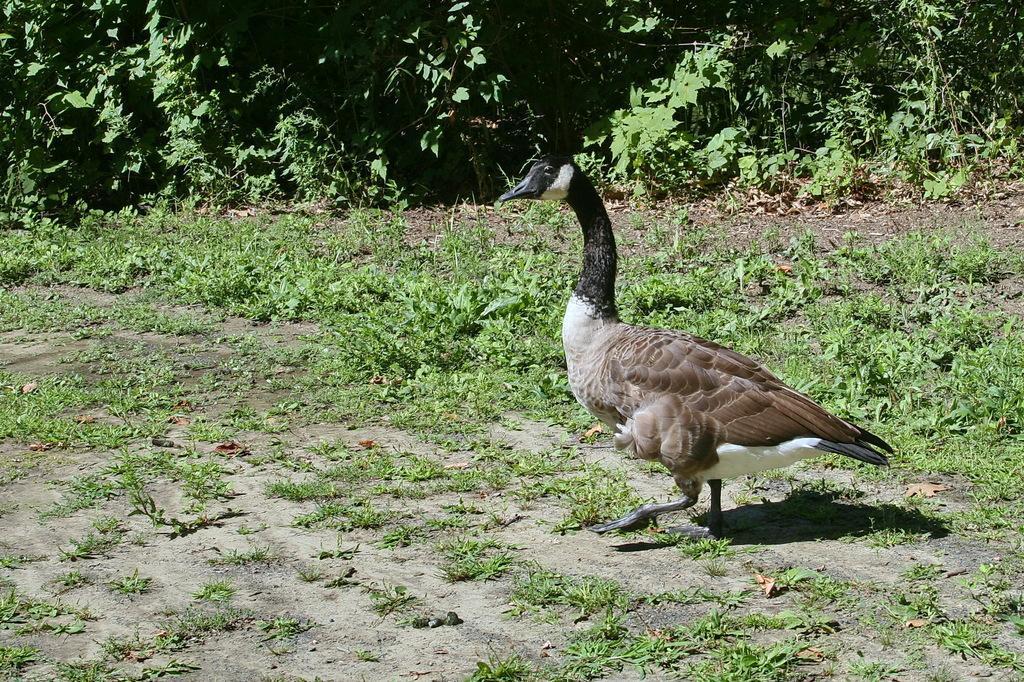How would you summarize this image in a sentence or two? In this picture, we see a goose. It is in black and brown color. It has a long black neck. At the bottom, we see the grass. In the middle, we see the herbs. There are trees in the background. 